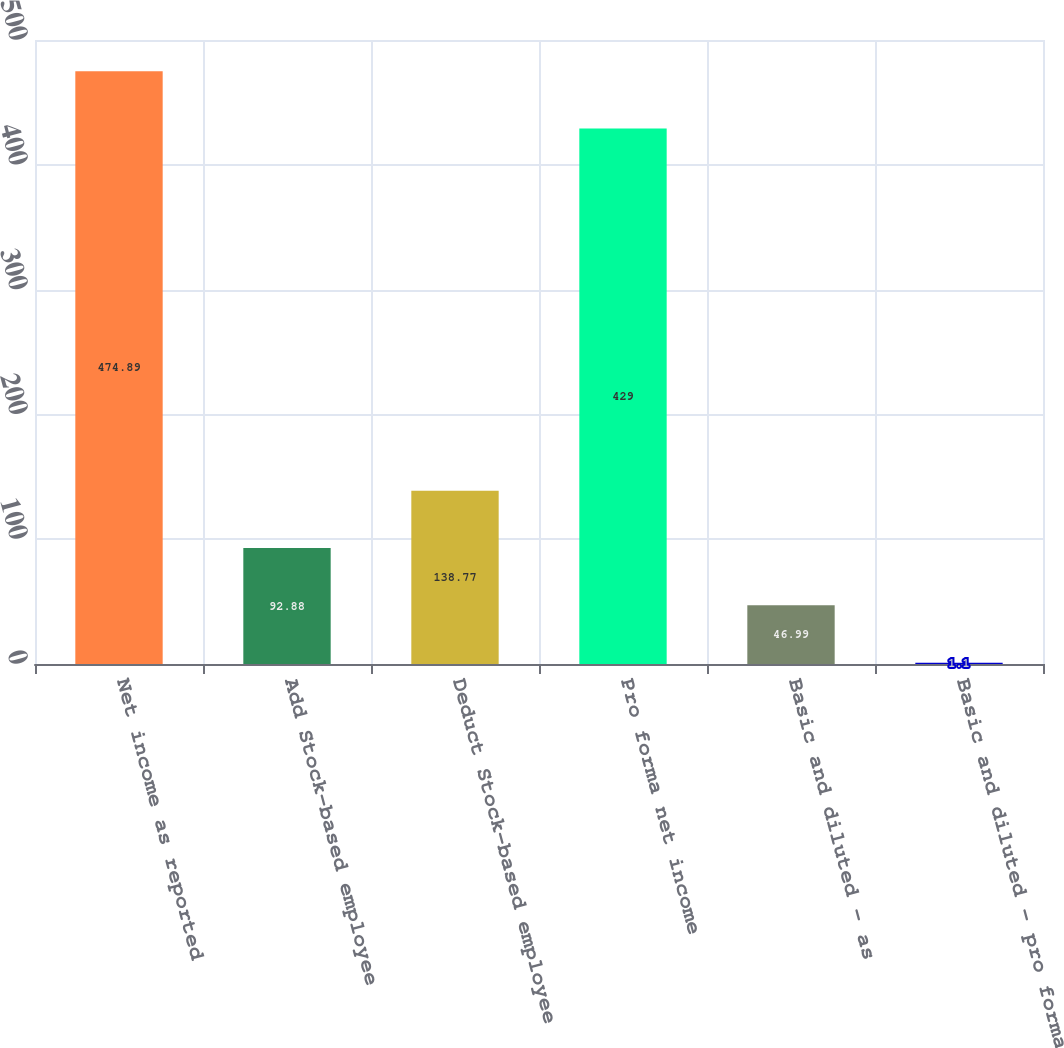Convert chart. <chart><loc_0><loc_0><loc_500><loc_500><bar_chart><fcel>Net income as reported<fcel>Add Stock-based employee<fcel>Deduct Stock-based employee<fcel>Pro forma net income<fcel>Basic and diluted - as<fcel>Basic and diluted - pro forma<nl><fcel>474.89<fcel>92.88<fcel>138.77<fcel>429<fcel>46.99<fcel>1.1<nl></chart> 